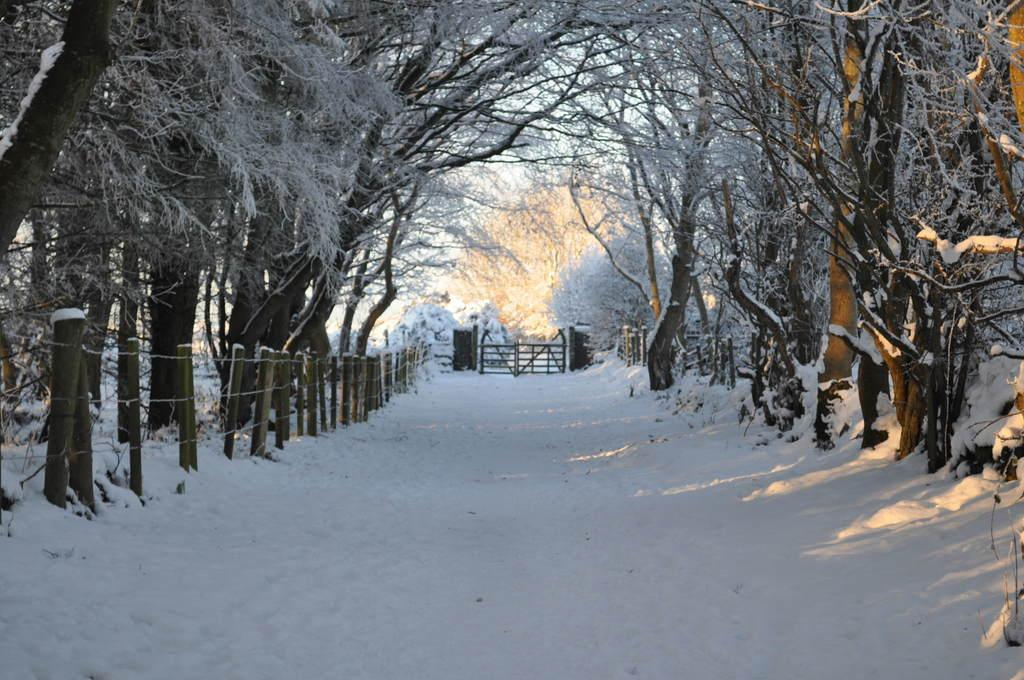What type of vegetation is present in the image? There are many trees in the image. What type of barrier can be seen in the image? There is a fence in the image. Is there an entrance in the fence? Yes, there is a gate in the image. What pathway is visible in the image? There is a walkway in the image. How is the walkway affected by the weather? The walkway is covered with snow in the image. Can you see the cook preparing a meal in the image? There is no cook or meal preparation visible in the image. Is there an owl perched on the fence in the image? There is no owl present in the image. 